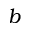<formula> <loc_0><loc_0><loc_500><loc_500>b</formula> 